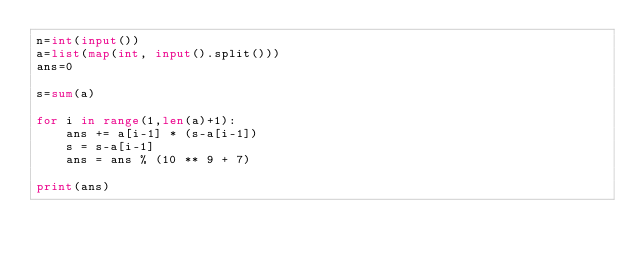<code> <loc_0><loc_0><loc_500><loc_500><_Python_>n=int(input())
a=list(map(int, input().split()))
ans=0

s=sum(a)

for i in range(1,len(a)+1):
    ans += a[i-1] * (s-a[i-1])
    s = s-a[i-1]
    ans = ans % (10 ** 9 + 7)

print(ans)</code> 